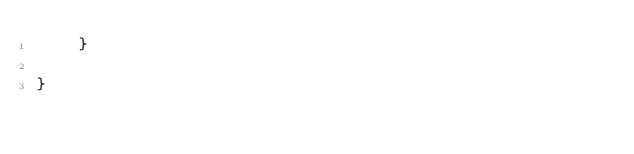<code> <loc_0><loc_0><loc_500><loc_500><_Java_>    }

}
</code> 